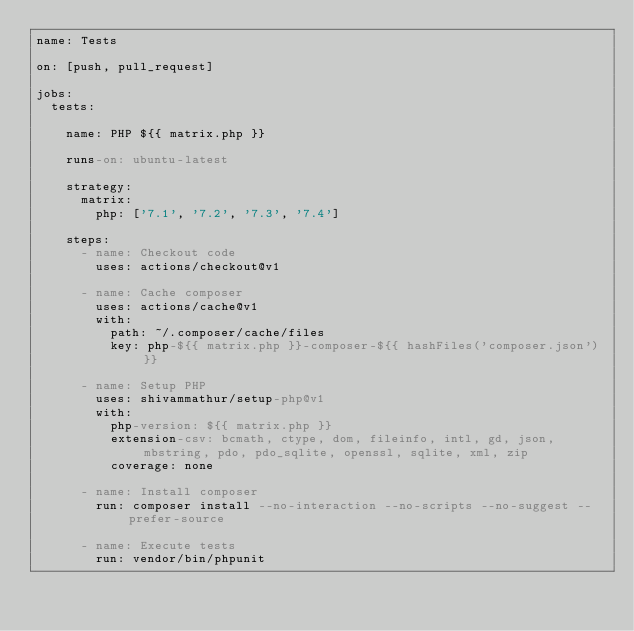<code> <loc_0><loc_0><loc_500><loc_500><_YAML_>name: Tests

on: [push, pull_request]

jobs:
  tests:

    name: PHP ${{ matrix.php }}

    runs-on: ubuntu-latest

    strategy:
      matrix:
        php: ['7.1', '7.2', '7.3', '7.4']

    steps:
      - name: Checkout code
        uses: actions/checkout@v1

      - name: Cache composer
        uses: actions/cache@v1
        with:
          path: ~/.composer/cache/files
          key: php-${{ matrix.php }}-composer-${{ hashFiles('composer.json') }}

      - name: Setup PHP
        uses: shivammathur/setup-php@v1
        with:
          php-version: ${{ matrix.php }}
          extension-csv: bcmath, ctype, dom, fileinfo, intl, gd, json, mbstring, pdo, pdo_sqlite, openssl, sqlite, xml, zip
          coverage: none

      - name: Install composer
        run: composer install --no-interaction --no-scripts --no-suggest --prefer-source

      - name: Execute tests
        run: vendor/bin/phpunit</code> 